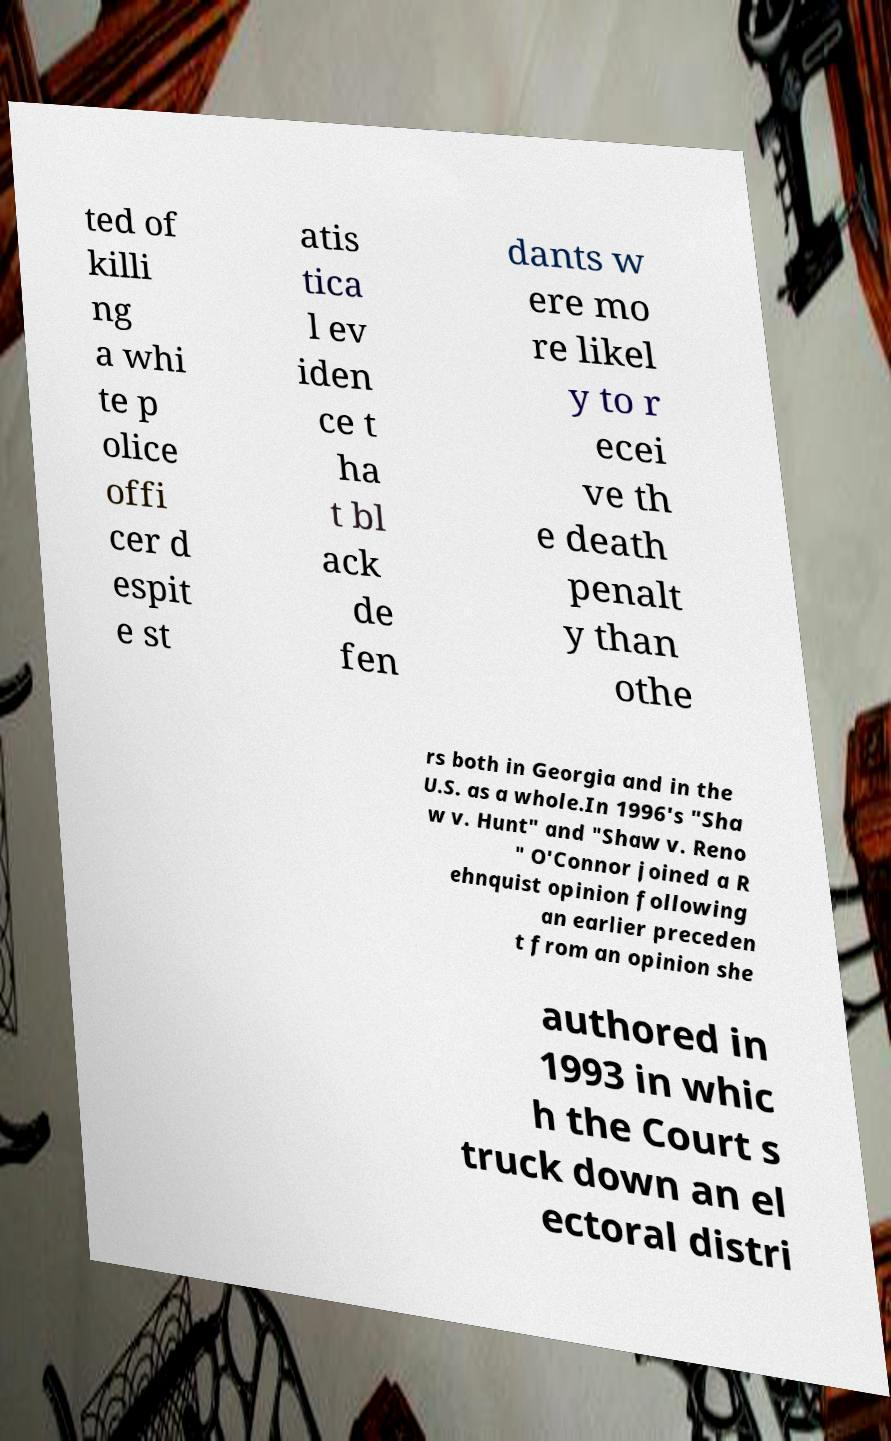I need the written content from this picture converted into text. Can you do that? ted of killi ng a whi te p olice offi cer d espit e st atis tica l ev iden ce t ha t bl ack de fen dants w ere mo re likel y to r ecei ve th e death penalt y than othe rs both in Georgia and in the U.S. as a whole.In 1996's "Sha w v. Hunt" and "Shaw v. Reno " O'Connor joined a R ehnquist opinion following an earlier preceden t from an opinion she authored in 1993 in whic h the Court s truck down an el ectoral distri 